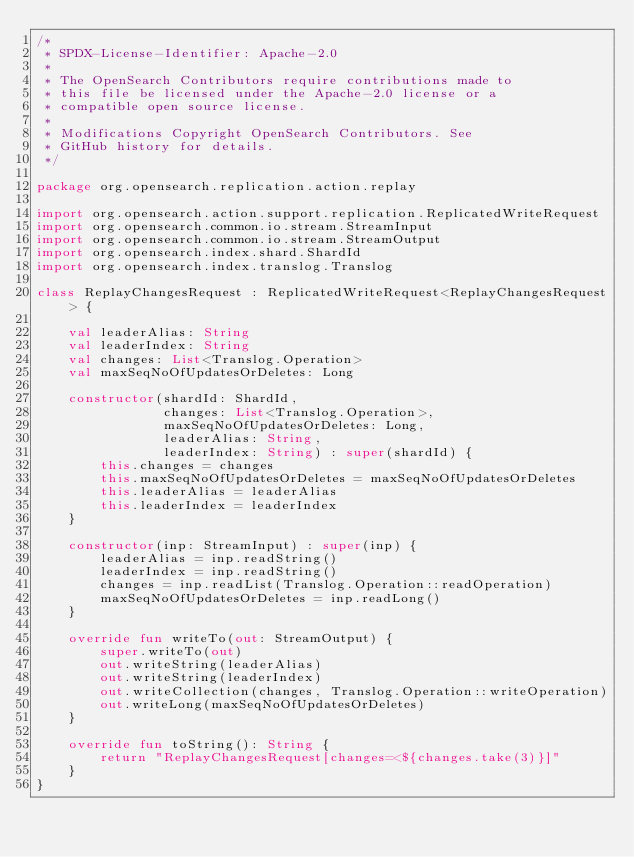<code> <loc_0><loc_0><loc_500><loc_500><_Kotlin_>/*
 * SPDX-License-Identifier: Apache-2.0
 *
 * The OpenSearch Contributors require contributions made to
 * this file be licensed under the Apache-2.0 license or a
 * compatible open source license.
 *
 * Modifications Copyright OpenSearch Contributors. See
 * GitHub history for details.
 */

package org.opensearch.replication.action.replay

import org.opensearch.action.support.replication.ReplicatedWriteRequest
import org.opensearch.common.io.stream.StreamInput
import org.opensearch.common.io.stream.StreamOutput
import org.opensearch.index.shard.ShardId
import org.opensearch.index.translog.Translog

class ReplayChangesRequest : ReplicatedWriteRequest<ReplayChangesRequest> {

    val leaderAlias: String
    val leaderIndex: String
    val changes: List<Translog.Operation>
    val maxSeqNoOfUpdatesOrDeletes: Long

    constructor(shardId: ShardId,
                changes: List<Translog.Operation>,
                maxSeqNoOfUpdatesOrDeletes: Long,
                leaderAlias: String,
                leaderIndex: String) : super(shardId) {
        this.changes = changes
        this.maxSeqNoOfUpdatesOrDeletes = maxSeqNoOfUpdatesOrDeletes
        this.leaderAlias = leaderAlias
        this.leaderIndex = leaderIndex
    }

    constructor(inp: StreamInput) : super(inp) {
        leaderAlias = inp.readString()
        leaderIndex = inp.readString()
        changes = inp.readList(Translog.Operation::readOperation)
        maxSeqNoOfUpdatesOrDeletes = inp.readLong()
    }

    override fun writeTo(out: StreamOutput) {
        super.writeTo(out)
        out.writeString(leaderAlias)
        out.writeString(leaderIndex)
        out.writeCollection(changes, Translog.Operation::writeOperation)
        out.writeLong(maxSeqNoOfUpdatesOrDeletes)
    }

    override fun toString(): String {
        return "ReplayChangesRequest[changes=<${changes.take(3)}]"
    }
}</code> 